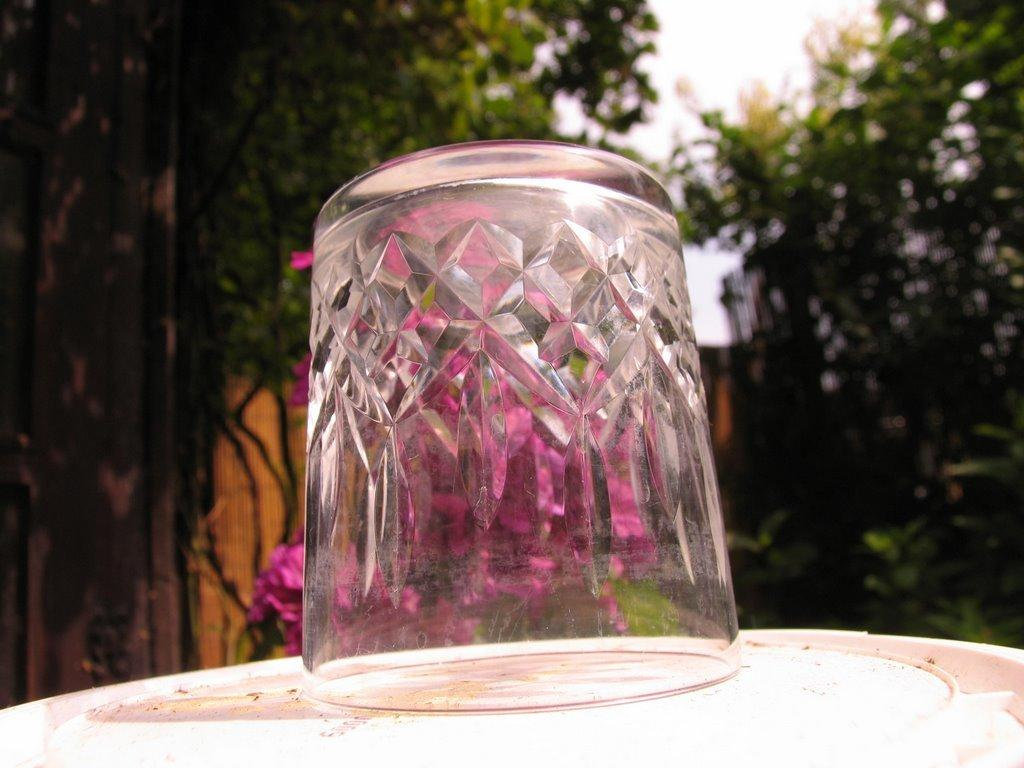What is the main subject of the image? There is a reverse glass on a white surface in the image. What type of flowers can be seen in the image? Pink flowers are present in the image. What other natural elements can be seen in the image? Trees are visible in the image. What type of lipstick is being used on the library in the image? There is no library or lipstick present in the image. 